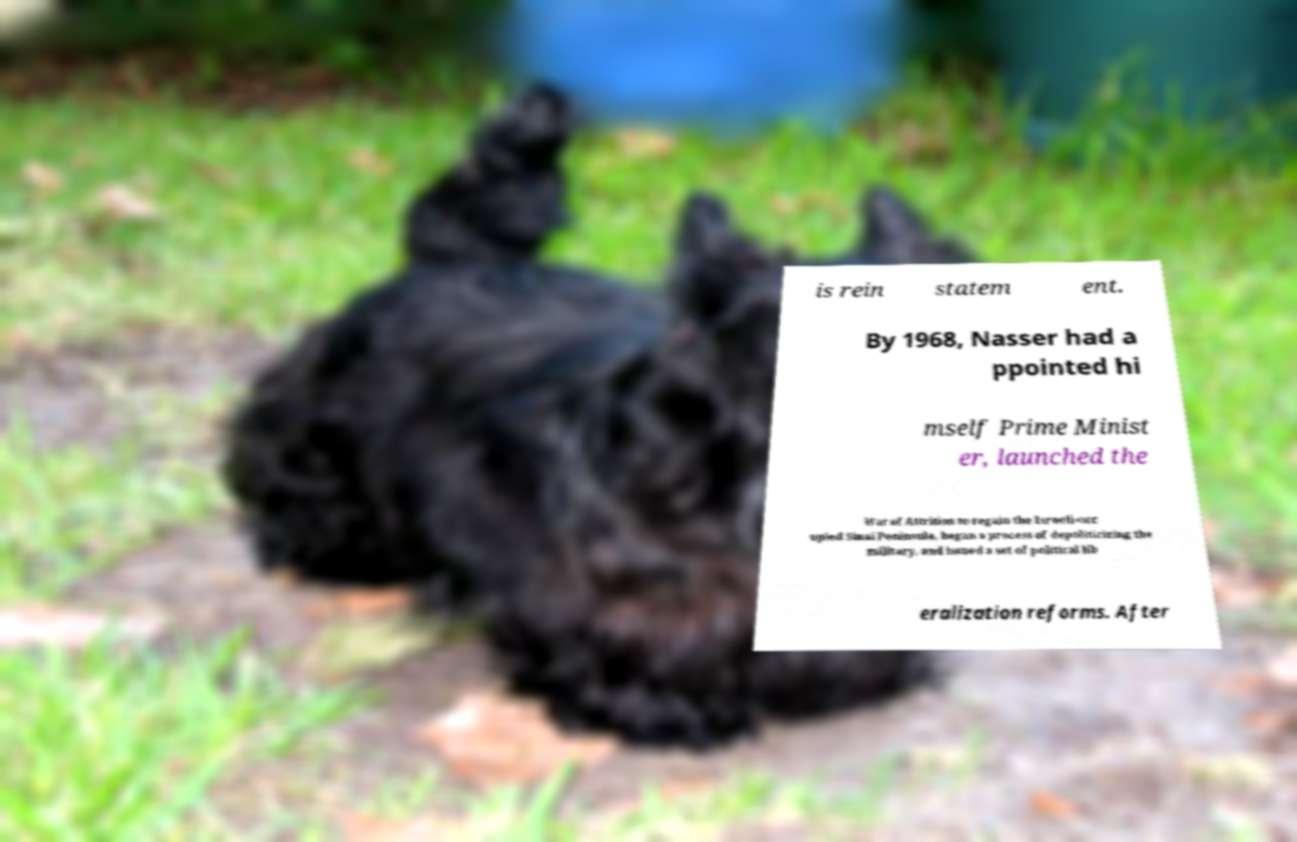Could you assist in decoding the text presented in this image and type it out clearly? is rein statem ent. By 1968, Nasser had a ppointed hi mself Prime Minist er, launched the War of Attrition to regain the Israeli-occ upied Sinai Peninsula, began a process of depoliticizing the military, and issued a set of political lib eralization reforms. After 